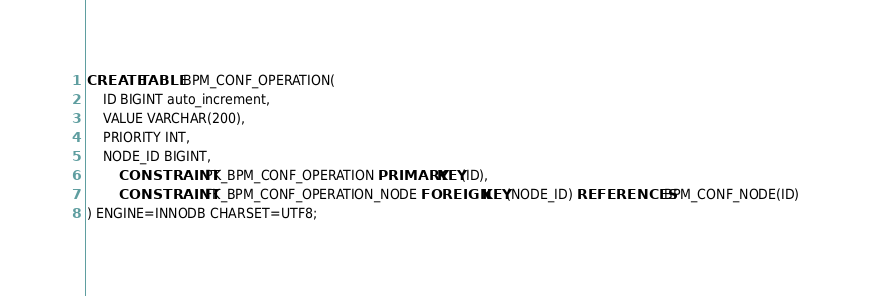Convert code to text. <code><loc_0><loc_0><loc_500><loc_500><_SQL_>
CREATE TABLE BPM_CONF_OPERATION(
	ID BIGINT auto_increment,
	VALUE VARCHAR(200),
	PRIORITY INT,
	NODE_ID BIGINT,
        CONSTRAINT PK_BPM_CONF_OPERATION PRIMARY KEY(ID),
        CONSTRAINT FK_BPM_CONF_OPERATION_NODE FOREIGN KEY(NODE_ID) REFERENCES BPM_CONF_NODE(ID)
) ENGINE=INNODB CHARSET=UTF8;

</code> 